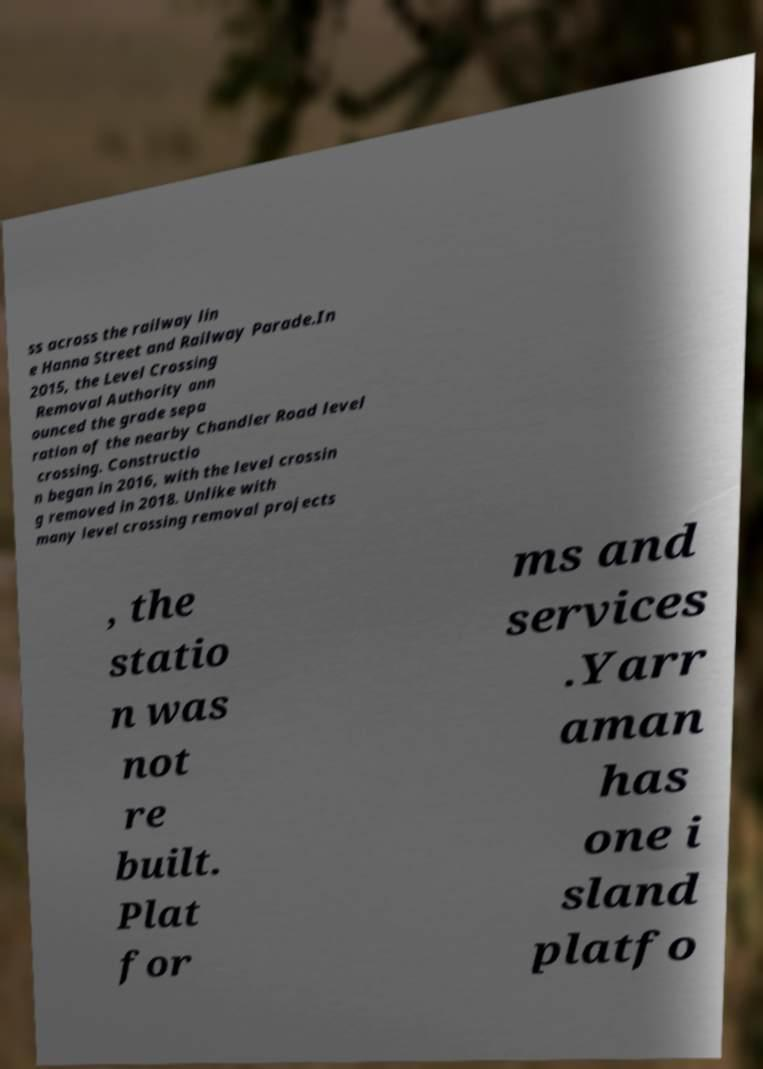For documentation purposes, I need the text within this image transcribed. Could you provide that? ss across the railway lin e Hanna Street and Railway Parade.In 2015, the Level Crossing Removal Authority ann ounced the grade sepa ration of the nearby Chandler Road level crossing. Constructio n began in 2016, with the level crossin g removed in 2018. Unlike with many level crossing removal projects , the statio n was not re built. Plat for ms and services .Yarr aman has one i sland platfo 